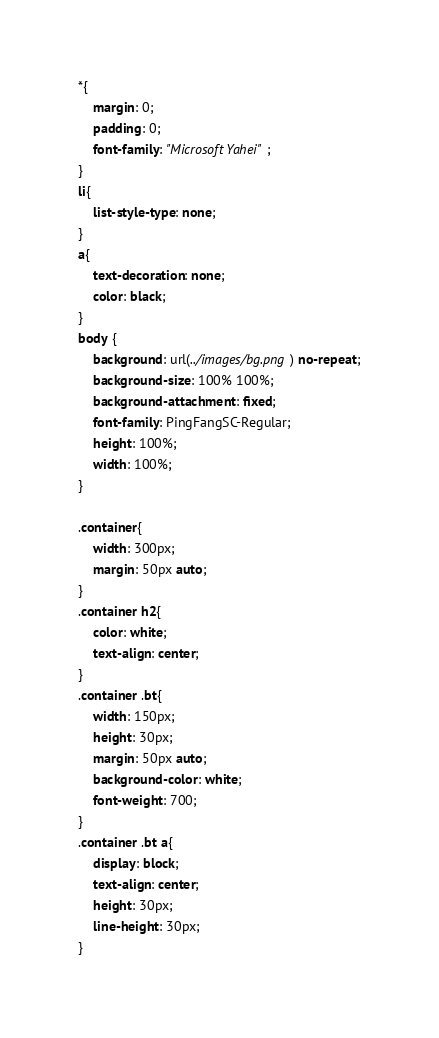<code> <loc_0><loc_0><loc_500><loc_500><_CSS_>*{
    margin: 0;
    padding: 0;
    font-family: "Microsoft Yahei";
}
li{
    list-style-type: none;
}
a{
    text-decoration: none;
    color: black;
}
body {
    background: url(../images/bg.png) no-repeat;
    background-size: 100% 100%;
    background-attachment: fixed;
    font-family: PingFangSC-Regular;
    height: 100%;
    width: 100%;
}

.container{
    width: 300px;
    margin: 50px auto;
}
.container h2{
    color: white;
    text-align: center;
}
.container .bt{
    width: 150px;
    height: 30px;
    margin: 50px auto;
    background-color: white;
    font-weight: 700;
}
.container .bt a{
    display: block;
    text-align: center;
    height: 30px;
    line-height: 30px;
}


</code> 